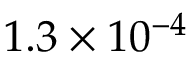Convert formula to latex. <formula><loc_0><loc_0><loc_500><loc_500>1 . 3 \times 1 0 ^ { - 4 }</formula> 